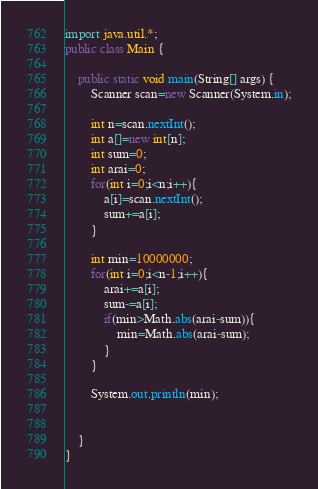Convert code to text. <code><loc_0><loc_0><loc_500><loc_500><_Java_>import java.util.*;
public class Main {

    public static void main(String[] args) {
        Scanner scan=new Scanner(System.in);

        int n=scan.nextInt();
        int a[]=new int[n];
        int sum=0;
        int arai=0;
        for(int i=0;i<n;i++){
            a[i]=scan.nextInt();
            sum+=a[i];
        }

        int min=10000000;
        for(int i=0;i<n-1;i++){
            arai+=a[i];
            sum-=a[i];
            if(min>Math.abs(arai-sum)){
                min=Math.abs(arai-sum);
            }
        }

        System.out.println(min);


    }
}</code> 